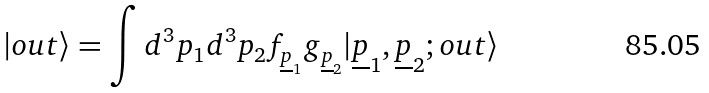Convert formula to latex. <formula><loc_0><loc_0><loc_500><loc_500>| { o u t } \rangle = \int { d ^ { 3 } p _ { 1 } d ^ { 3 } p _ { 2 } f _ { \underline { p } _ { 1 } } g _ { \underline { p } _ { 2 } } | { \underline { p } _ { 1 } , \underline { p } _ { 2 } ; o u t } \rangle }</formula> 